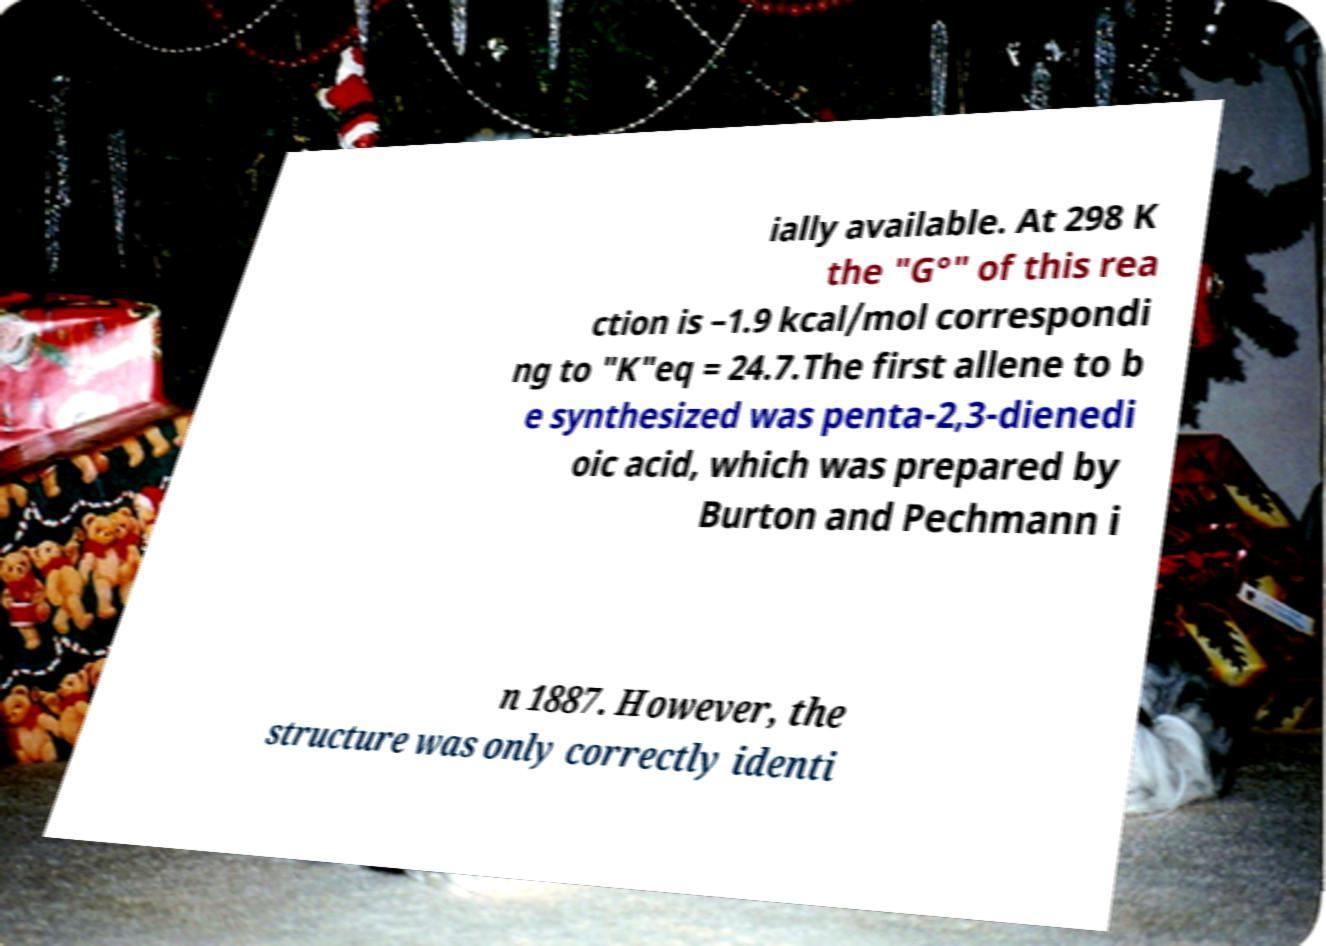There's text embedded in this image that I need extracted. Can you transcribe it verbatim? ially available. At 298 K the "G°" of this rea ction is –1.9 kcal/mol correspondi ng to "K"eq = 24.7.The first allene to b e synthesized was penta-2,3-dienedi oic acid, which was prepared by Burton and Pechmann i n 1887. However, the structure was only correctly identi 